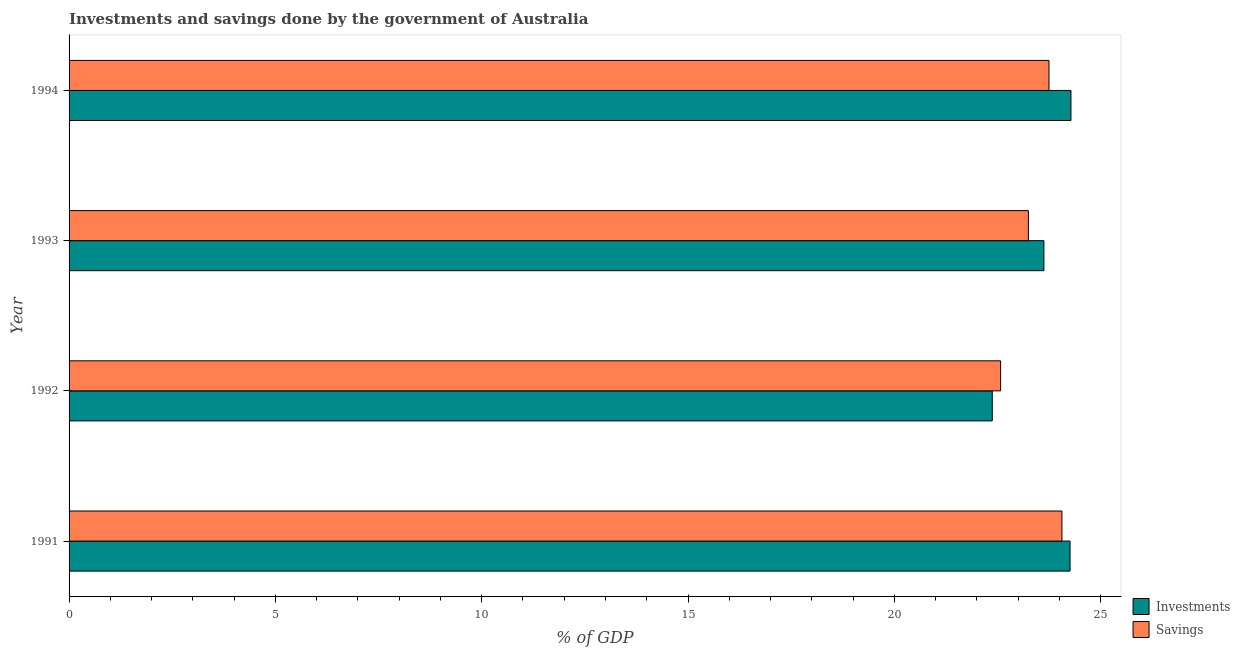How many different coloured bars are there?
Your answer should be compact. 2. Are the number of bars on each tick of the Y-axis equal?
Your answer should be very brief. Yes. How many bars are there on the 1st tick from the top?
Provide a succinct answer. 2. How many bars are there on the 1st tick from the bottom?
Your answer should be compact. 2. What is the label of the 3rd group of bars from the top?
Your response must be concise. 1992. In how many cases, is the number of bars for a given year not equal to the number of legend labels?
Your answer should be compact. 0. What is the savings of government in 1992?
Ensure brevity in your answer.  22.58. Across all years, what is the maximum investments of government?
Keep it short and to the point. 24.28. Across all years, what is the minimum savings of government?
Keep it short and to the point. 22.58. In which year was the savings of government minimum?
Provide a succinct answer. 1992. What is the total investments of government in the graph?
Your answer should be very brief. 94.54. What is the difference between the investments of government in 1991 and that in 1992?
Your answer should be very brief. 1.89. What is the difference between the savings of government in 1991 and the investments of government in 1992?
Ensure brevity in your answer.  1.69. What is the average investments of government per year?
Your answer should be very brief. 23.64. In the year 1991, what is the difference between the savings of government and investments of government?
Offer a very short reply. -0.2. In how many years, is the savings of government greater than 21 %?
Your answer should be compact. 4. Is the investments of government in 1993 less than that in 1994?
Ensure brevity in your answer.  Yes. Is the difference between the savings of government in 1992 and 1993 greater than the difference between the investments of government in 1992 and 1993?
Keep it short and to the point. Yes. What is the difference between the highest and the second highest savings of government?
Offer a very short reply. 0.31. What is the difference between the highest and the lowest investments of government?
Your answer should be very brief. 1.91. Is the sum of the investments of government in 1993 and 1994 greater than the maximum savings of government across all years?
Give a very brief answer. Yes. What does the 1st bar from the top in 1991 represents?
Offer a very short reply. Savings. What does the 1st bar from the bottom in 1994 represents?
Offer a very short reply. Investments. How many bars are there?
Your answer should be compact. 8. What is the difference between two consecutive major ticks on the X-axis?
Offer a very short reply. 5. Are the values on the major ticks of X-axis written in scientific E-notation?
Your response must be concise. No. Does the graph contain any zero values?
Your response must be concise. No. Does the graph contain grids?
Offer a very short reply. No. How many legend labels are there?
Keep it short and to the point. 2. How are the legend labels stacked?
Keep it short and to the point. Vertical. What is the title of the graph?
Provide a succinct answer. Investments and savings done by the government of Australia. Does "Primary completion rate" appear as one of the legend labels in the graph?
Offer a very short reply. No. What is the label or title of the X-axis?
Ensure brevity in your answer.  % of GDP. What is the label or title of the Y-axis?
Offer a very short reply. Year. What is the % of GDP of Investments in 1991?
Provide a short and direct response. 24.26. What is the % of GDP in Savings in 1991?
Offer a terse response. 24.06. What is the % of GDP in Investments in 1992?
Offer a terse response. 22.37. What is the % of GDP of Savings in 1992?
Your answer should be compact. 22.58. What is the % of GDP in Investments in 1993?
Keep it short and to the point. 23.63. What is the % of GDP of Savings in 1993?
Offer a very short reply. 23.25. What is the % of GDP of Investments in 1994?
Make the answer very short. 24.28. What is the % of GDP of Savings in 1994?
Your answer should be very brief. 23.75. Across all years, what is the maximum % of GDP in Investments?
Offer a very short reply. 24.28. Across all years, what is the maximum % of GDP in Savings?
Your answer should be compact. 24.06. Across all years, what is the minimum % of GDP in Investments?
Make the answer very short. 22.37. Across all years, what is the minimum % of GDP in Savings?
Offer a terse response. 22.58. What is the total % of GDP in Investments in the graph?
Your answer should be very brief. 94.54. What is the total % of GDP in Savings in the graph?
Provide a short and direct response. 93.64. What is the difference between the % of GDP in Investments in 1991 and that in 1992?
Keep it short and to the point. 1.89. What is the difference between the % of GDP of Savings in 1991 and that in 1992?
Offer a terse response. 1.49. What is the difference between the % of GDP in Investments in 1991 and that in 1993?
Provide a short and direct response. 0.63. What is the difference between the % of GDP in Savings in 1991 and that in 1993?
Offer a very short reply. 0.81. What is the difference between the % of GDP in Investments in 1991 and that in 1994?
Offer a terse response. -0.02. What is the difference between the % of GDP of Savings in 1991 and that in 1994?
Your answer should be compact. 0.31. What is the difference between the % of GDP of Investments in 1992 and that in 1993?
Your answer should be compact. -1.25. What is the difference between the % of GDP in Savings in 1992 and that in 1993?
Make the answer very short. -0.67. What is the difference between the % of GDP in Investments in 1992 and that in 1994?
Offer a very short reply. -1.91. What is the difference between the % of GDP in Savings in 1992 and that in 1994?
Make the answer very short. -1.17. What is the difference between the % of GDP of Investments in 1993 and that in 1994?
Your response must be concise. -0.66. What is the difference between the % of GDP in Savings in 1993 and that in 1994?
Give a very brief answer. -0.5. What is the difference between the % of GDP of Investments in 1991 and the % of GDP of Savings in 1992?
Provide a short and direct response. 1.68. What is the difference between the % of GDP of Investments in 1991 and the % of GDP of Savings in 1993?
Offer a terse response. 1.01. What is the difference between the % of GDP in Investments in 1991 and the % of GDP in Savings in 1994?
Give a very brief answer. 0.51. What is the difference between the % of GDP in Investments in 1992 and the % of GDP in Savings in 1993?
Ensure brevity in your answer.  -0.88. What is the difference between the % of GDP in Investments in 1992 and the % of GDP in Savings in 1994?
Your answer should be very brief. -1.37. What is the difference between the % of GDP in Investments in 1993 and the % of GDP in Savings in 1994?
Provide a succinct answer. -0.12. What is the average % of GDP of Investments per year?
Your answer should be compact. 23.64. What is the average % of GDP of Savings per year?
Give a very brief answer. 23.41. In the year 1991, what is the difference between the % of GDP of Investments and % of GDP of Savings?
Provide a succinct answer. 0.2. In the year 1992, what is the difference between the % of GDP of Investments and % of GDP of Savings?
Your answer should be compact. -0.2. In the year 1993, what is the difference between the % of GDP in Investments and % of GDP in Savings?
Provide a short and direct response. 0.38. In the year 1994, what is the difference between the % of GDP of Investments and % of GDP of Savings?
Your response must be concise. 0.53. What is the ratio of the % of GDP of Investments in 1991 to that in 1992?
Offer a very short reply. 1.08. What is the ratio of the % of GDP of Savings in 1991 to that in 1992?
Keep it short and to the point. 1.07. What is the ratio of the % of GDP of Investments in 1991 to that in 1993?
Provide a short and direct response. 1.03. What is the ratio of the % of GDP in Savings in 1991 to that in 1993?
Make the answer very short. 1.03. What is the ratio of the % of GDP in Savings in 1991 to that in 1994?
Ensure brevity in your answer.  1.01. What is the ratio of the % of GDP in Investments in 1992 to that in 1993?
Make the answer very short. 0.95. What is the ratio of the % of GDP of Savings in 1992 to that in 1993?
Ensure brevity in your answer.  0.97. What is the ratio of the % of GDP of Investments in 1992 to that in 1994?
Your answer should be compact. 0.92. What is the ratio of the % of GDP in Savings in 1992 to that in 1994?
Give a very brief answer. 0.95. What is the ratio of the % of GDP in Investments in 1993 to that in 1994?
Provide a succinct answer. 0.97. What is the difference between the highest and the second highest % of GDP of Investments?
Your answer should be very brief. 0.02. What is the difference between the highest and the second highest % of GDP of Savings?
Ensure brevity in your answer.  0.31. What is the difference between the highest and the lowest % of GDP in Investments?
Your response must be concise. 1.91. What is the difference between the highest and the lowest % of GDP of Savings?
Keep it short and to the point. 1.49. 